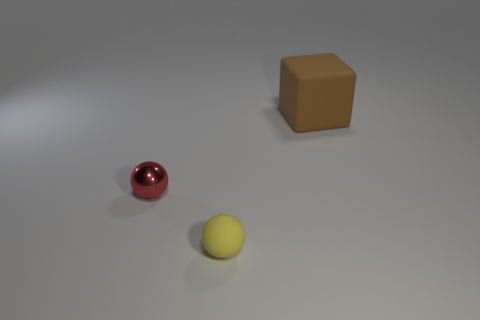Add 3 small yellow metal cylinders. How many objects exist? 6 Subtract all blocks. How many objects are left? 2 Subtract all tiny blocks. Subtract all yellow balls. How many objects are left? 2 Add 1 balls. How many balls are left? 3 Add 2 cyan cubes. How many cyan cubes exist? 2 Subtract 1 yellow balls. How many objects are left? 2 